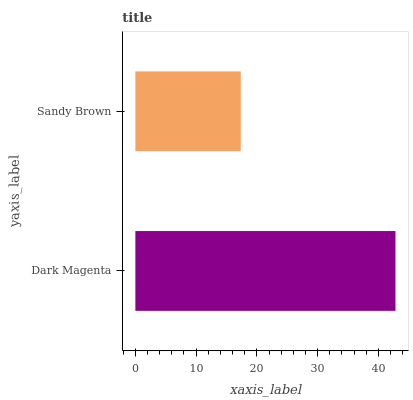Is Sandy Brown the minimum?
Answer yes or no. Yes. Is Dark Magenta the maximum?
Answer yes or no. Yes. Is Sandy Brown the maximum?
Answer yes or no. No. Is Dark Magenta greater than Sandy Brown?
Answer yes or no. Yes. Is Sandy Brown less than Dark Magenta?
Answer yes or no. Yes. Is Sandy Brown greater than Dark Magenta?
Answer yes or no. No. Is Dark Magenta less than Sandy Brown?
Answer yes or no. No. Is Dark Magenta the high median?
Answer yes or no. Yes. Is Sandy Brown the low median?
Answer yes or no. Yes. Is Sandy Brown the high median?
Answer yes or no. No. Is Dark Magenta the low median?
Answer yes or no. No. 